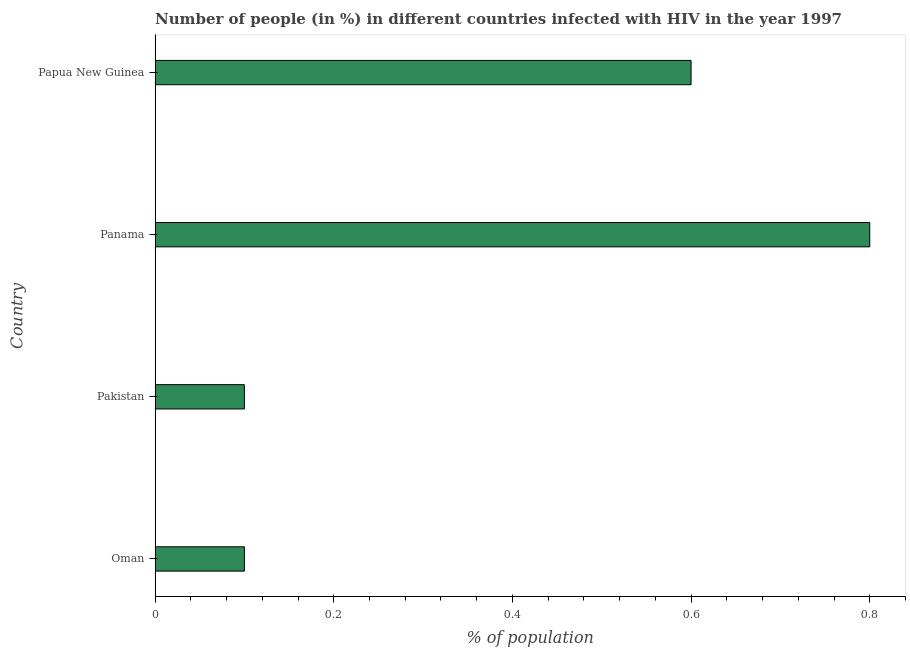Does the graph contain any zero values?
Keep it short and to the point. No. Does the graph contain grids?
Offer a very short reply. No. What is the title of the graph?
Offer a very short reply. Number of people (in %) in different countries infected with HIV in the year 1997. What is the label or title of the X-axis?
Make the answer very short. % of population. What is the label or title of the Y-axis?
Your answer should be compact. Country. Across all countries, what is the maximum number of people infected with hiv?
Give a very brief answer. 0.8. Across all countries, what is the minimum number of people infected with hiv?
Keep it short and to the point. 0.1. In which country was the number of people infected with hiv maximum?
Make the answer very short. Panama. In which country was the number of people infected with hiv minimum?
Give a very brief answer. Oman. What is the median number of people infected with hiv?
Make the answer very short. 0.35. In how many countries, is the number of people infected with hiv greater than 0.52 %?
Keep it short and to the point. 2. What is the ratio of the number of people infected with hiv in Oman to that in Papua New Guinea?
Your answer should be very brief. 0.17. What is the difference between the highest and the second highest number of people infected with hiv?
Offer a terse response. 0.2. Is the sum of the number of people infected with hiv in Panama and Papua New Guinea greater than the maximum number of people infected with hiv across all countries?
Your answer should be compact. Yes. What is the difference between the highest and the lowest number of people infected with hiv?
Keep it short and to the point. 0.7. How many bars are there?
Provide a short and direct response. 4. Are all the bars in the graph horizontal?
Provide a succinct answer. Yes. Are the values on the major ticks of X-axis written in scientific E-notation?
Your answer should be compact. No. What is the % of population in Panama?
Give a very brief answer. 0.8. What is the % of population of Papua New Guinea?
Your response must be concise. 0.6. What is the difference between the % of population in Pakistan and Panama?
Provide a short and direct response. -0.7. What is the difference between the % of population in Pakistan and Papua New Guinea?
Give a very brief answer. -0.5. What is the difference between the % of population in Panama and Papua New Guinea?
Your response must be concise. 0.2. What is the ratio of the % of population in Oman to that in Papua New Guinea?
Ensure brevity in your answer.  0.17. What is the ratio of the % of population in Pakistan to that in Papua New Guinea?
Offer a very short reply. 0.17. What is the ratio of the % of population in Panama to that in Papua New Guinea?
Ensure brevity in your answer.  1.33. 